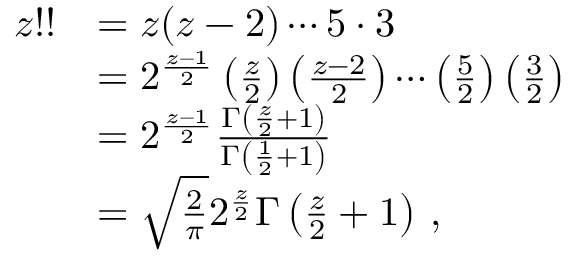<formula> <loc_0><loc_0><loc_500><loc_500>{ \begin{array} { r l } { z ! ! } & { = z ( z - 2 ) \cdots 5 \cdot 3 } \\ & { = 2 ^ { \frac { z - 1 } { 2 } } \left ( { \frac { z } { 2 } } \right ) \left ( { \frac { z - 2 } { 2 } } \right ) \cdots \left ( { \frac { 5 } { 2 } } \right ) \left ( { \frac { 3 } { 2 } } \right ) } \\ & { = 2 ^ { \frac { z - 1 } { 2 } } { \frac { \Gamma \left ( { \frac { z } { 2 } } + 1 \right ) } { \Gamma \left ( { \frac { 1 } { 2 } } + 1 \right ) } } } \\ & { = { \sqrt { \frac { 2 } { \pi } } } 2 ^ { \frac { z } { 2 } } \Gamma \left ( { \frac { z } { 2 } } + 1 \right ) \, , } \end{array} }</formula> 